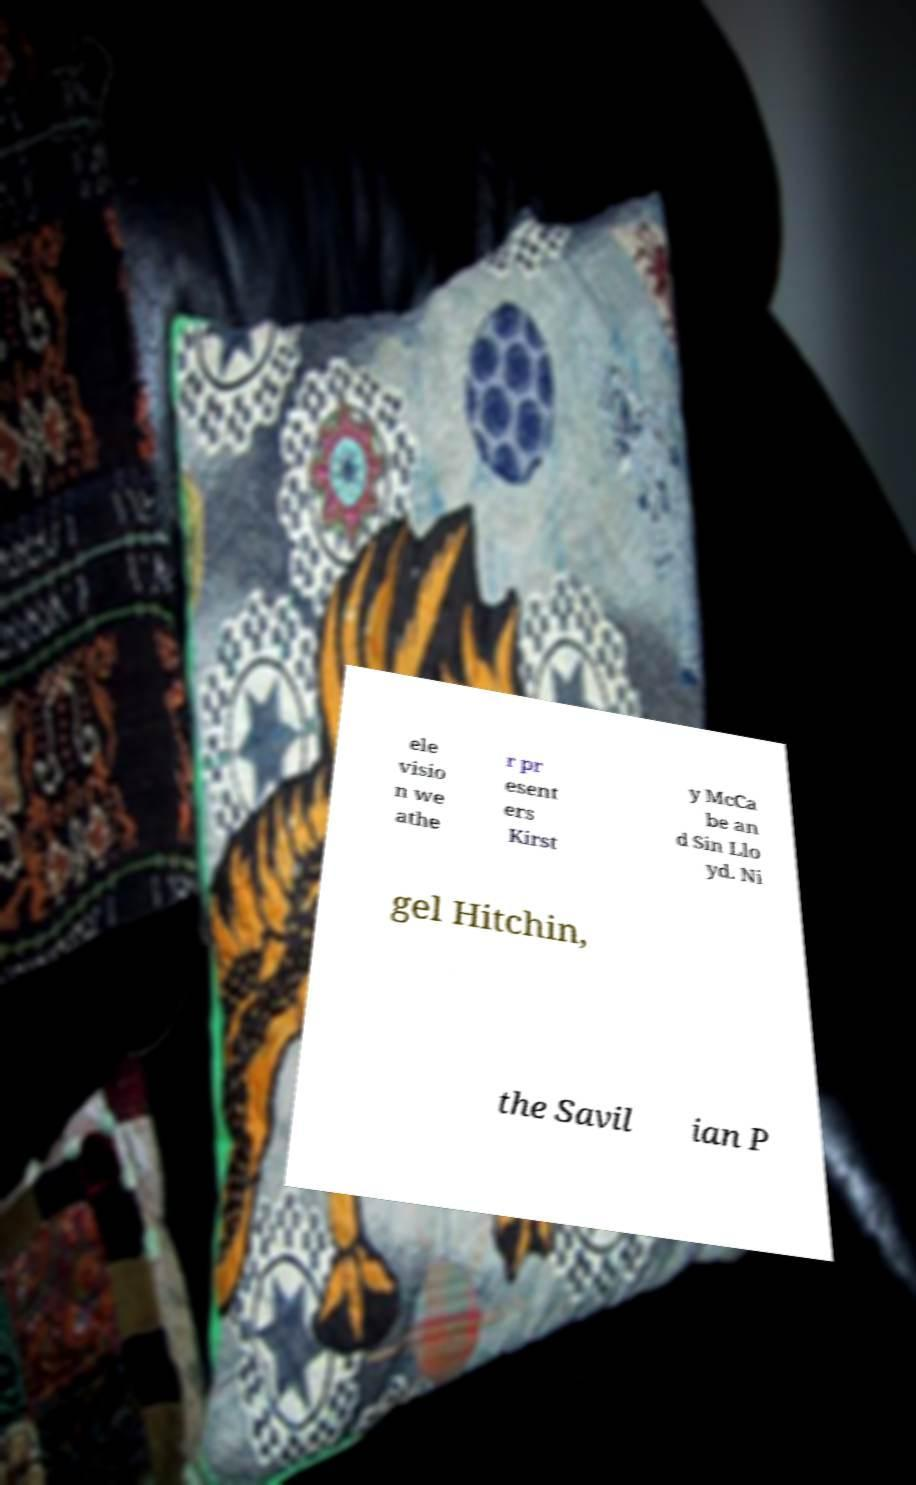For documentation purposes, I need the text within this image transcribed. Could you provide that? ele visio n we athe r pr esent ers Kirst y McCa be an d Sin Llo yd. Ni gel Hitchin, the Savil ian P 